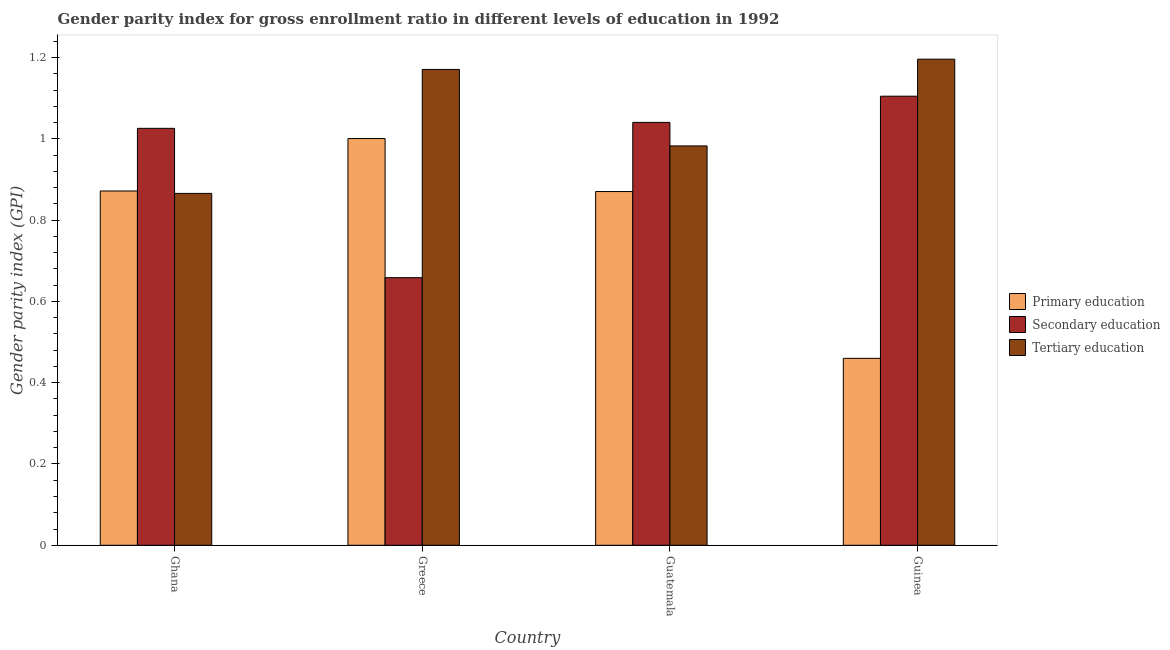How many groups of bars are there?
Make the answer very short. 4. Are the number of bars on each tick of the X-axis equal?
Your response must be concise. Yes. What is the label of the 4th group of bars from the left?
Offer a very short reply. Guinea. What is the gender parity index in tertiary education in Greece?
Your answer should be compact. 1.17. Across all countries, what is the maximum gender parity index in primary education?
Offer a very short reply. 1. Across all countries, what is the minimum gender parity index in tertiary education?
Give a very brief answer. 0.87. In which country was the gender parity index in secondary education maximum?
Keep it short and to the point. Guinea. In which country was the gender parity index in primary education minimum?
Keep it short and to the point. Guinea. What is the total gender parity index in tertiary education in the graph?
Your answer should be compact. 4.22. What is the difference between the gender parity index in primary education in Ghana and that in Greece?
Your answer should be very brief. -0.13. What is the difference between the gender parity index in primary education in Ghana and the gender parity index in tertiary education in Greece?
Offer a terse response. -0.3. What is the average gender parity index in secondary education per country?
Offer a very short reply. 0.96. What is the difference between the gender parity index in tertiary education and gender parity index in primary education in Guatemala?
Your answer should be very brief. 0.11. In how many countries, is the gender parity index in primary education greater than 0.56 ?
Your response must be concise. 3. What is the ratio of the gender parity index in primary education in Ghana to that in Guinea?
Offer a terse response. 1.9. What is the difference between the highest and the second highest gender parity index in secondary education?
Keep it short and to the point. 0.06. What is the difference between the highest and the lowest gender parity index in primary education?
Ensure brevity in your answer.  0.54. What does the 3rd bar from the left in Guatemala represents?
Your answer should be compact. Tertiary education. What does the 2nd bar from the right in Ghana represents?
Provide a short and direct response. Secondary education. Is it the case that in every country, the sum of the gender parity index in primary education and gender parity index in secondary education is greater than the gender parity index in tertiary education?
Provide a short and direct response. Yes. Are the values on the major ticks of Y-axis written in scientific E-notation?
Make the answer very short. No. Does the graph contain any zero values?
Give a very brief answer. No. Does the graph contain grids?
Make the answer very short. No. How are the legend labels stacked?
Give a very brief answer. Vertical. What is the title of the graph?
Offer a terse response. Gender parity index for gross enrollment ratio in different levels of education in 1992. What is the label or title of the X-axis?
Offer a terse response. Country. What is the label or title of the Y-axis?
Provide a succinct answer. Gender parity index (GPI). What is the Gender parity index (GPI) in Primary education in Ghana?
Make the answer very short. 0.87. What is the Gender parity index (GPI) in Secondary education in Ghana?
Provide a succinct answer. 1.03. What is the Gender parity index (GPI) of Tertiary education in Ghana?
Offer a very short reply. 0.87. What is the Gender parity index (GPI) in Primary education in Greece?
Keep it short and to the point. 1. What is the Gender parity index (GPI) in Secondary education in Greece?
Make the answer very short. 0.66. What is the Gender parity index (GPI) of Tertiary education in Greece?
Your answer should be compact. 1.17. What is the Gender parity index (GPI) in Primary education in Guatemala?
Provide a succinct answer. 0.87. What is the Gender parity index (GPI) in Secondary education in Guatemala?
Provide a short and direct response. 1.04. What is the Gender parity index (GPI) of Tertiary education in Guatemala?
Keep it short and to the point. 0.98. What is the Gender parity index (GPI) of Primary education in Guinea?
Provide a short and direct response. 0.46. What is the Gender parity index (GPI) of Secondary education in Guinea?
Your answer should be compact. 1.1. What is the Gender parity index (GPI) in Tertiary education in Guinea?
Offer a terse response. 1.2. Across all countries, what is the maximum Gender parity index (GPI) in Primary education?
Offer a terse response. 1. Across all countries, what is the maximum Gender parity index (GPI) of Secondary education?
Keep it short and to the point. 1.1. Across all countries, what is the maximum Gender parity index (GPI) of Tertiary education?
Your answer should be very brief. 1.2. Across all countries, what is the minimum Gender parity index (GPI) in Primary education?
Ensure brevity in your answer.  0.46. Across all countries, what is the minimum Gender parity index (GPI) of Secondary education?
Offer a terse response. 0.66. Across all countries, what is the minimum Gender parity index (GPI) of Tertiary education?
Your answer should be very brief. 0.87. What is the total Gender parity index (GPI) of Primary education in the graph?
Give a very brief answer. 3.2. What is the total Gender parity index (GPI) of Secondary education in the graph?
Make the answer very short. 3.83. What is the total Gender parity index (GPI) of Tertiary education in the graph?
Provide a short and direct response. 4.22. What is the difference between the Gender parity index (GPI) of Primary education in Ghana and that in Greece?
Give a very brief answer. -0.13. What is the difference between the Gender parity index (GPI) in Secondary education in Ghana and that in Greece?
Your answer should be compact. 0.37. What is the difference between the Gender parity index (GPI) of Tertiary education in Ghana and that in Greece?
Provide a succinct answer. -0.3. What is the difference between the Gender parity index (GPI) in Primary education in Ghana and that in Guatemala?
Offer a terse response. 0. What is the difference between the Gender parity index (GPI) in Secondary education in Ghana and that in Guatemala?
Your answer should be very brief. -0.01. What is the difference between the Gender parity index (GPI) of Tertiary education in Ghana and that in Guatemala?
Provide a short and direct response. -0.12. What is the difference between the Gender parity index (GPI) in Primary education in Ghana and that in Guinea?
Offer a terse response. 0.41. What is the difference between the Gender parity index (GPI) in Secondary education in Ghana and that in Guinea?
Provide a succinct answer. -0.08. What is the difference between the Gender parity index (GPI) in Tertiary education in Ghana and that in Guinea?
Make the answer very short. -0.33. What is the difference between the Gender parity index (GPI) in Primary education in Greece and that in Guatemala?
Provide a short and direct response. 0.13. What is the difference between the Gender parity index (GPI) of Secondary education in Greece and that in Guatemala?
Your answer should be compact. -0.38. What is the difference between the Gender parity index (GPI) of Tertiary education in Greece and that in Guatemala?
Your response must be concise. 0.19. What is the difference between the Gender parity index (GPI) of Primary education in Greece and that in Guinea?
Your answer should be compact. 0.54. What is the difference between the Gender parity index (GPI) of Secondary education in Greece and that in Guinea?
Your response must be concise. -0.45. What is the difference between the Gender parity index (GPI) of Tertiary education in Greece and that in Guinea?
Your answer should be compact. -0.03. What is the difference between the Gender parity index (GPI) of Primary education in Guatemala and that in Guinea?
Keep it short and to the point. 0.41. What is the difference between the Gender parity index (GPI) in Secondary education in Guatemala and that in Guinea?
Give a very brief answer. -0.06. What is the difference between the Gender parity index (GPI) of Tertiary education in Guatemala and that in Guinea?
Your answer should be very brief. -0.21. What is the difference between the Gender parity index (GPI) of Primary education in Ghana and the Gender parity index (GPI) of Secondary education in Greece?
Make the answer very short. 0.21. What is the difference between the Gender parity index (GPI) in Primary education in Ghana and the Gender parity index (GPI) in Tertiary education in Greece?
Give a very brief answer. -0.3. What is the difference between the Gender parity index (GPI) of Secondary education in Ghana and the Gender parity index (GPI) of Tertiary education in Greece?
Your answer should be very brief. -0.14. What is the difference between the Gender parity index (GPI) of Primary education in Ghana and the Gender parity index (GPI) of Secondary education in Guatemala?
Offer a very short reply. -0.17. What is the difference between the Gender parity index (GPI) in Primary education in Ghana and the Gender parity index (GPI) in Tertiary education in Guatemala?
Your response must be concise. -0.11. What is the difference between the Gender parity index (GPI) in Secondary education in Ghana and the Gender parity index (GPI) in Tertiary education in Guatemala?
Offer a terse response. 0.04. What is the difference between the Gender parity index (GPI) in Primary education in Ghana and the Gender parity index (GPI) in Secondary education in Guinea?
Offer a terse response. -0.23. What is the difference between the Gender parity index (GPI) of Primary education in Ghana and the Gender parity index (GPI) of Tertiary education in Guinea?
Offer a terse response. -0.32. What is the difference between the Gender parity index (GPI) of Secondary education in Ghana and the Gender parity index (GPI) of Tertiary education in Guinea?
Provide a short and direct response. -0.17. What is the difference between the Gender parity index (GPI) of Primary education in Greece and the Gender parity index (GPI) of Secondary education in Guatemala?
Your response must be concise. -0.04. What is the difference between the Gender parity index (GPI) of Primary education in Greece and the Gender parity index (GPI) of Tertiary education in Guatemala?
Give a very brief answer. 0.02. What is the difference between the Gender parity index (GPI) of Secondary education in Greece and the Gender parity index (GPI) of Tertiary education in Guatemala?
Your answer should be very brief. -0.32. What is the difference between the Gender parity index (GPI) of Primary education in Greece and the Gender parity index (GPI) of Secondary education in Guinea?
Your answer should be very brief. -0.1. What is the difference between the Gender parity index (GPI) of Primary education in Greece and the Gender parity index (GPI) of Tertiary education in Guinea?
Give a very brief answer. -0.2. What is the difference between the Gender parity index (GPI) of Secondary education in Greece and the Gender parity index (GPI) of Tertiary education in Guinea?
Your response must be concise. -0.54. What is the difference between the Gender parity index (GPI) of Primary education in Guatemala and the Gender parity index (GPI) of Secondary education in Guinea?
Ensure brevity in your answer.  -0.23. What is the difference between the Gender parity index (GPI) in Primary education in Guatemala and the Gender parity index (GPI) in Tertiary education in Guinea?
Your response must be concise. -0.33. What is the difference between the Gender parity index (GPI) of Secondary education in Guatemala and the Gender parity index (GPI) of Tertiary education in Guinea?
Provide a succinct answer. -0.16. What is the average Gender parity index (GPI) in Primary education per country?
Your answer should be very brief. 0.8. What is the average Gender parity index (GPI) of Secondary education per country?
Offer a terse response. 0.96. What is the average Gender parity index (GPI) in Tertiary education per country?
Offer a terse response. 1.05. What is the difference between the Gender parity index (GPI) in Primary education and Gender parity index (GPI) in Secondary education in Ghana?
Make the answer very short. -0.15. What is the difference between the Gender parity index (GPI) in Primary education and Gender parity index (GPI) in Tertiary education in Ghana?
Offer a terse response. 0.01. What is the difference between the Gender parity index (GPI) in Secondary education and Gender parity index (GPI) in Tertiary education in Ghana?
Your response must be concise. 0.16. What is the difference between the Gender parity index (GPI) of Primary education and Gender parity index (GPI) of Secondary education in Greece?
Your response must be concise. 0.34. What is the difference between the Gender parity index (GPI) in Primary education and Gender parity index (GPI) in Tertiary education in Greece?
Ensure brevity in your answer.  -0.17. What is the difference between the Gender parity index (GPI) of Secondary education and Gender parity index (GPI) of Tertiary education in Greece?
Offer a very short reply. -0.51. What is the difference between the Gender parity index (GPI) in Primary education and Gender parity index (GPI) in Secondary education in Guatemala?
Keep it short and to the point. -0.17. What is the difference between the Gender parity index (GPI) of Primary education and Gender parity index (GPI) of Tertiary education in Guatemala?
Your response must be concise. -0.11. What is the difference between the Gender parity index (GPI) in Secondary education and Gender parity index (GPI) in Tertiary education in Guatemala?
Your answer should be compact. 0.06. What is the difference between the Gender parity index (GPI) in Primary education and Gender parity index (GPI) in Secondary education in Guinea?
Keep it short and to the point. -0.65. What is the difference between the Gender parity index (GPI) of Primary education and Gender parity index (GPI) of Tertiary education in Guinea?
Offer a terse response. -0.74. What is the difference between the Gender parity index (GPI) of Secondary education and Gender parity index (GPI) of Tertiary education in Guinea?
Give a very brief answer. -0.09. What is the ratio of the Gender parity index (GPI) of Primary education in Ghana to that in Greece?
Your answer should be very brief. 0.87. What is the ratio of the Gender parity index (GPI) in Secondary education in Ghana to that in Greece?
Make the answer very short. 1.56. What is the ratio of the Gender parity index (GPI) in Tertiary education in Ghana to that in Greece?
Make the answer very short. 0.74. What is the ratio of the Gender parity index (GPI) in Secondary education in Ghana to that in Guatemala?
Keep it short and to the point. 0.99. What is the ratio of the Gender parity index (GPI) in Tertiary education in Ghana to that in Guatemala?
Keep it short and to the point. 0.88. What is the ratio of the Gender parity index (GPI) in Primary education in Ghana to that in Guinea?
Offer a very short reply. 1.9. What is the ratio of the Gender parity index (GPI) of Secondary education in Ghana to that in Guinea?
Your answer should be very brief. 0.93. What is the ratio of the Gender parity index (GPI) of Tertiary education in Ghana to that in Guinea?
Make the answer very short. 0.72. What is the ratio of the Gender parity index (GPI) of Primary education in Greece to that in Guatemala?
Offer a very short reply. 1.15. What is the ratio of the Gender parity index (GPI) of Secondary education in Greece to that in Guatemala?
Give a very brief answer. 0.63. What is the ratio of the Gender parity index (GPI) in Tertiary education in Greece to that in Guatemala?
Provide a succinct answer. 1.19. What is the ratio of the Gender parity index (GPI) in Primary education in Greece to that in Guinea?
Ensure brevity in your answer.  2.18. What is the ratio of the Gender parity index (GPI) of Secondary education in Greece to that in Guinea?
Keep it short and to the point. 0.6. What is the ratio of the Gender parity index (GPI) in Tertiary education in Greece to that in Guinea?
Offer a very short reply. 0.98. What is the ratio of the Gender parity index (GPI) in Primary education in Guatemala to that in Guinea?
Keep it short and to the point. 1.89. What is the ratio of the Gender parity index (GPI) of Secondary education in Guatemala to that in Guinea?
Your answer should be compact. 0.94. What is the ratio of the Gender parity index (GPI) in Tertiary education in Guatemala to that in Guinea?
Provide a succinct answer. 0.82. What is the difference between the highest and the second highest Gender parity index (GPI) in Primary education?
Your response must be concise. 0.13. What is the difference between the highest and the second highest Gender parity index (GPI) in Secondary education?
Your answer should be very brief. 0.06. What is the difference between the highest and the second highest Gender parity index (GPI) in Tertiary education?
Provide a short and direct response. 0.03. What is the difference between the highest and the lowest Gender parity index (GPI) in Primary education?
Offer a very short reply. 0.54. What is the difference between the highest and the lowest Gender parity index (GPI) of Secondary education?
Provide a succinct answer. 0.45. What is the difference between the highest and the lowest Gender parity index (GPI) of Tertiary education?
Offer a very short reply. 0.33. 